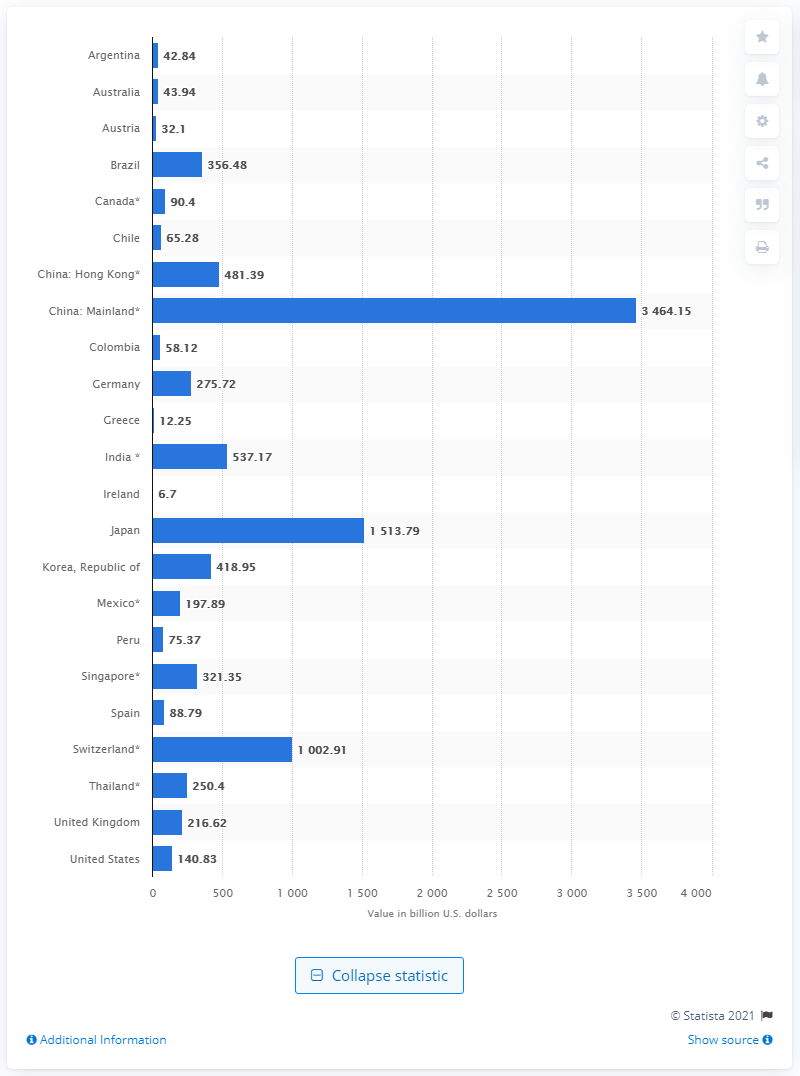How do China's reserves compare to those of other countries? Based on the image, China's reserves are substantially higher than those of any other country listed. For instance, Japan, the next country with the highest reserves, has around 1.514 trillion U.S. dollars, which is less than half of China's reserves. This exemplifies China's economic strength and the scale of its currency reserves. What might be the implications of China having such a large amount of reserves? China’s vast reserves provide substantial advantages. They allow the country to manage currency values to facilitate trade, provide a buffer against financial crises, and give the government flexibility in international relations. This reserve can also be invested to generate returns or used as a strategic tool in negotiations with other countries. 